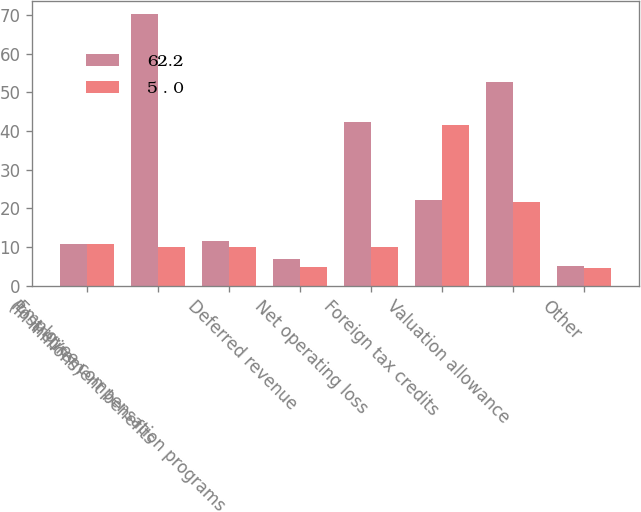Convert chart to OTSL. <chart><loc_0><loc_0><loc_500><loc_500><stacked_bar_chart><ecel><fcel>(In millions)<fcel>Postretirement benefits<fcel>Employee compensation programs<fcel>Deferred revenue<fcel>Net operating loss<fcel>Foreign tax credits<fcel>Valuation allowance<fcel>Other<nl><fcel>62.2<fcel>10.75<fcel>70.2<fcel>11.5<fcel>6.9<fcel>42.3<fcel>22.2<fcel>52.7<fcel>5<nl><fcel>5 . 0<fcel>10.75<fcel>10<fcel>9.9<fcel>4.7<fcel>9.9<fcel>41.5<fcel>21.6<fcel>4.6<nl></chart> 